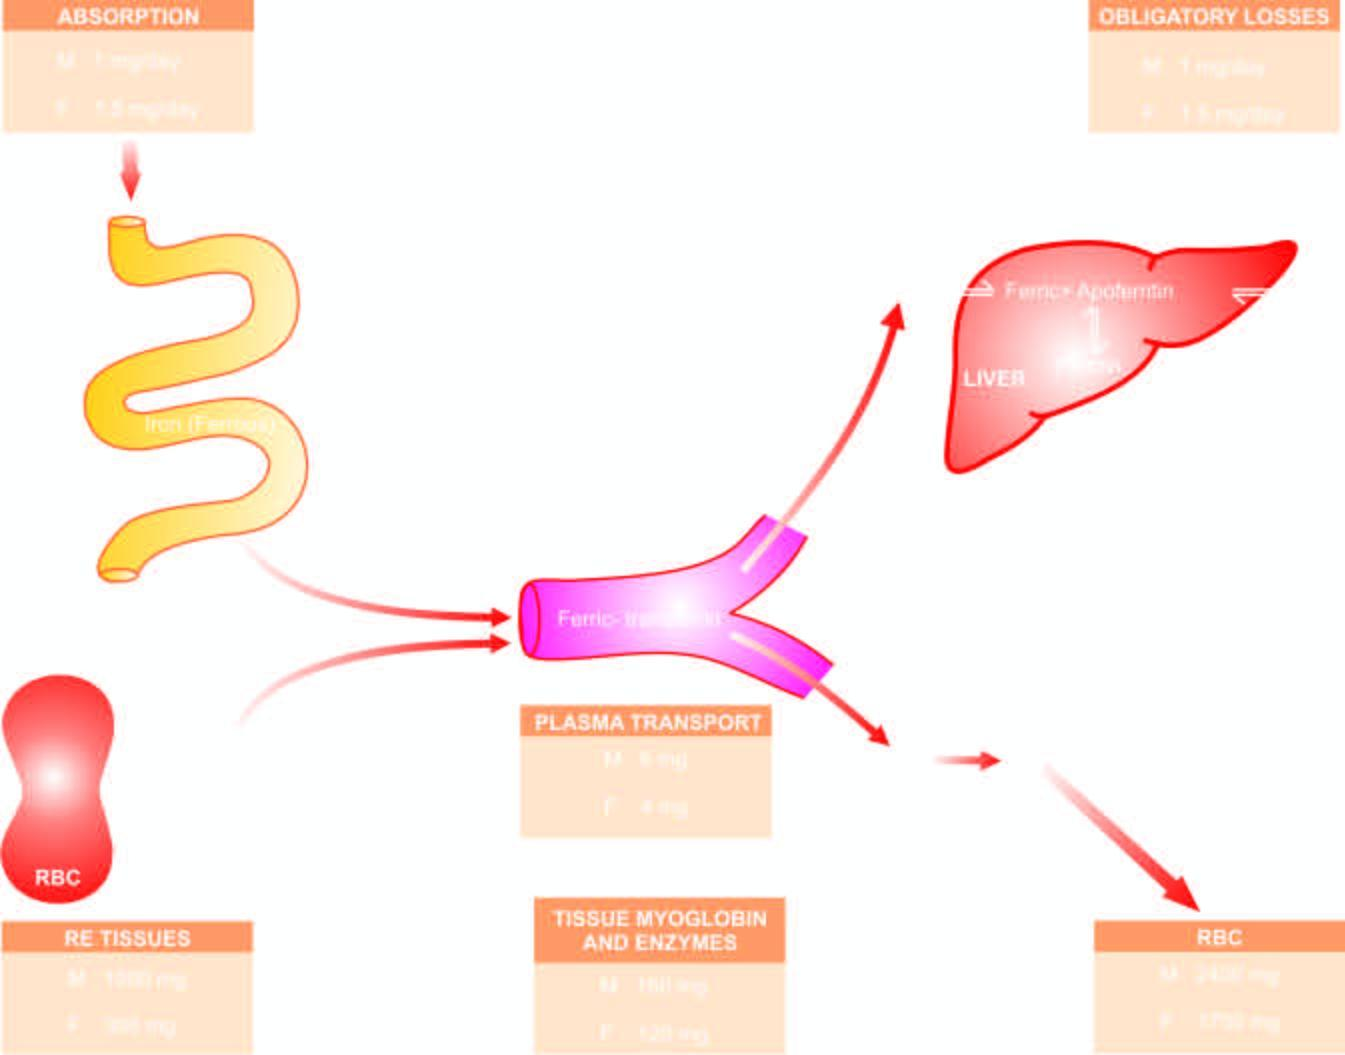s amyloid mobilised in response to increased demand and used for haemoglobin synthesis, thus completing the cycle m = males ; f = females?
Answer the question using a single word or phrase. No 